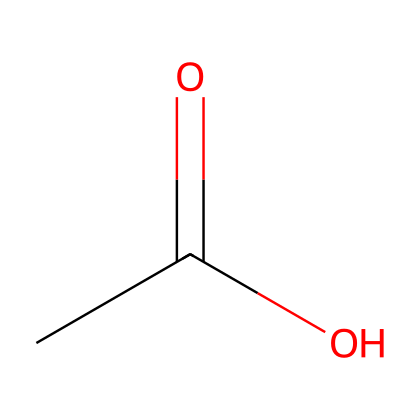What is the chemical name of this compound? The structure represented by the SMILES CC(=O)O corresponds to a molecule with a carboxylic acid functional group. This compound is commonly known as acetic acid, which is the main component of vinegar.
Answer: acetic acid How many carbon atoms are present in this molecule? Looking at the SMILES structure CC(=O)O, there are two carbon atoms indicated by the two "C" letters.
Answer: 2 What type of functional group is present in acetic acid? The SMILES CC(=O)O shows the presence of a carboxylic acid functional group, which can be identified by the -COOH part of the structure.
Answer: carboxylic acid How many hydrogen atoms are in acetic acid? From the SMILES CC(=O)O, we can derive the number of hydrogen atoms. Each carbon in this molecule has enough hydrogen atoms to satisfy its valency of four. The first carbon is connected to three hydrogen atoms and the second carbon is part of the carboxylic acid group, suggesting it has one hydrogen. Thus, the total is 4 hydrogen atoms.
Answer: 4 What is the pH nature of acetic acid? Since acetic acid is a weak acid, it partially dissociates in water, leading to a decrease in pH. Weak acids typically have a pH below 7 but above 3.
Answer: acidic Does acetic acid have a sour taste? Acetic acid is well-known for its sour taste, which is characteristic of many acids, especially those found in food items like vinegar.
Answer: yes Is acetic acid a volatile substance? Acetic acid has a relatively low boiling point (about 118 degrees Celsius), indicating that it can evaporate quickly at room temperature, which is a characteristic of volatile substances.
Answer: yes 